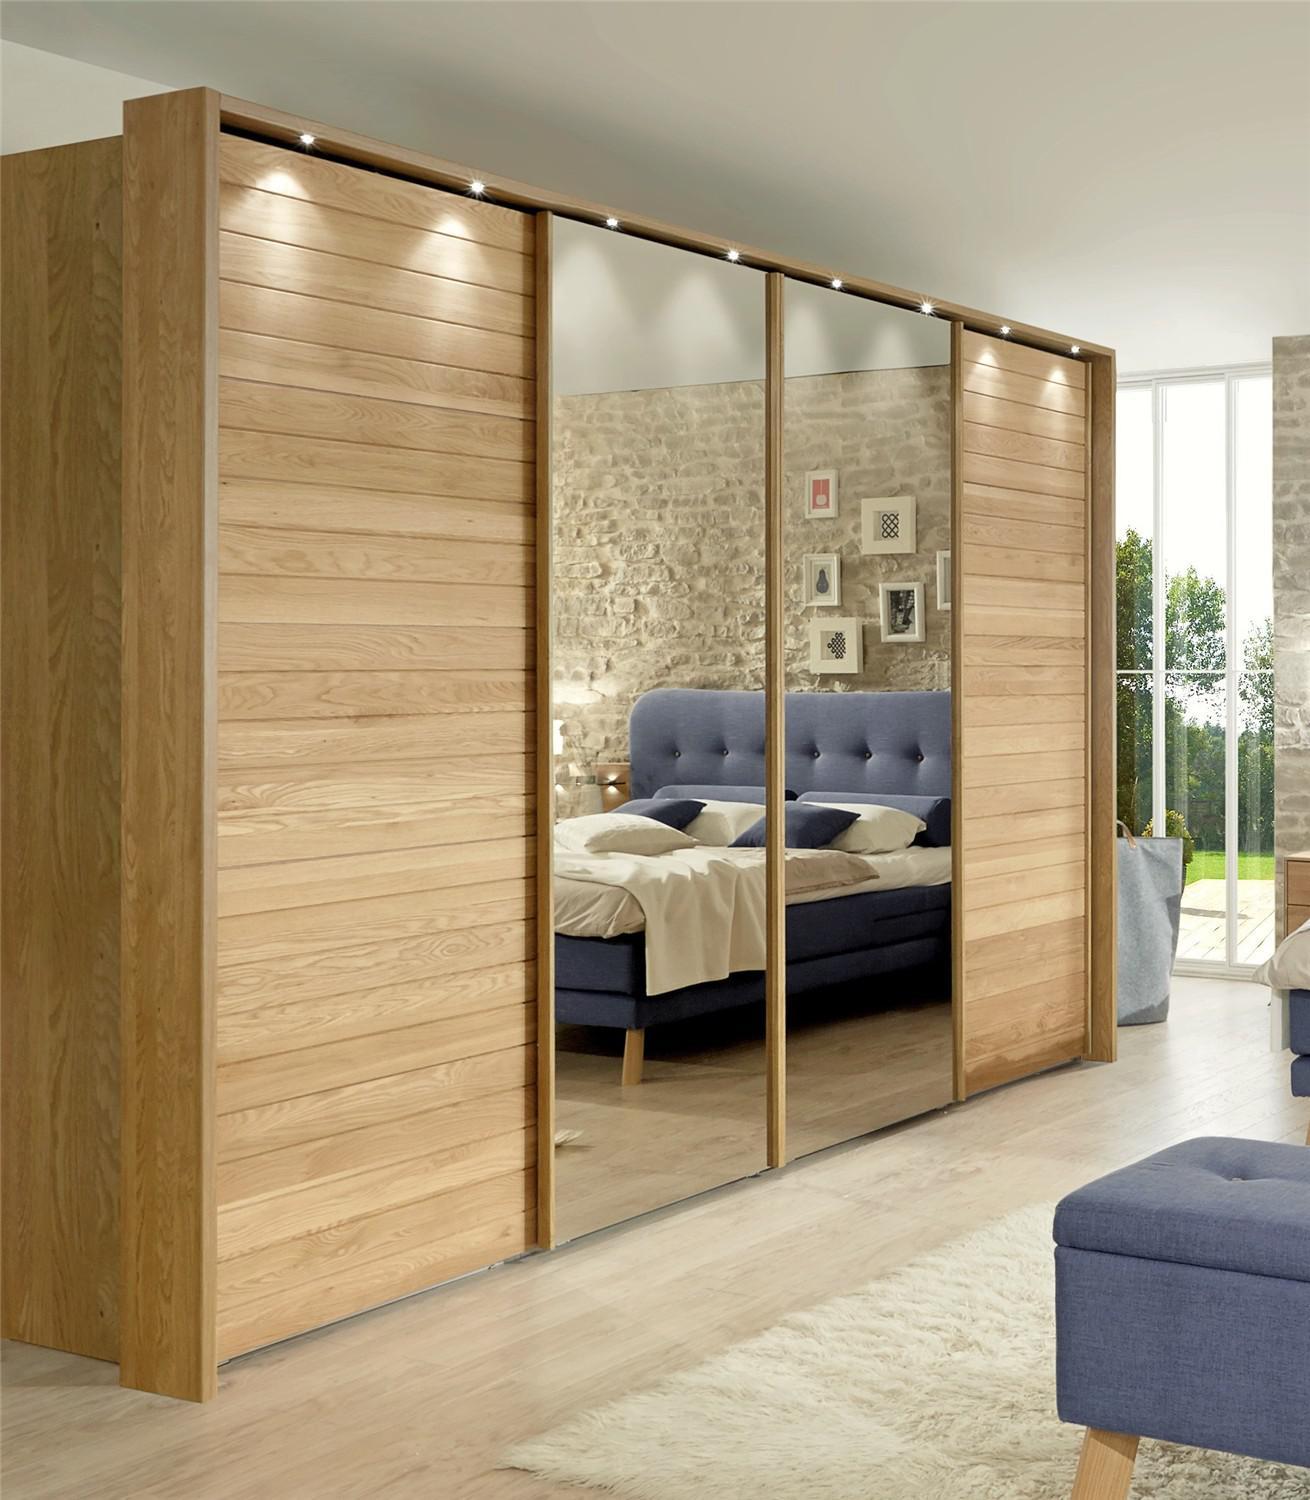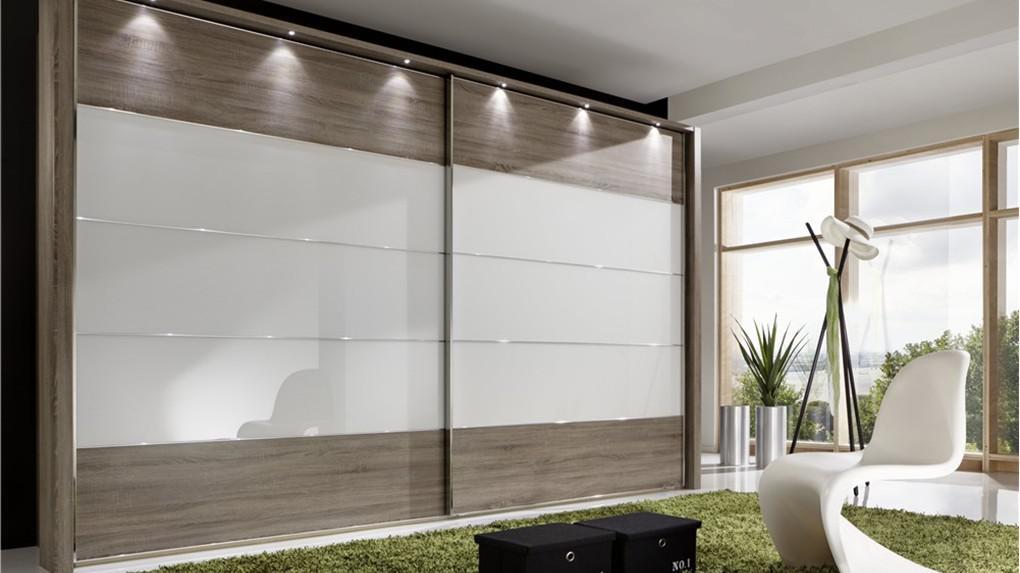The first image is the image on the left, the second image is the image on the right. Evaluate the accuracy of this statement regarding the images: "A plant is near a sliding cabinet in one of the images.". Is it true? Answer yes or no. Yes. The first image is the image on the left, the second image is the image on the right. Assess this claim about the two images: "An image shows a closed sliding-door unit with at least one mirrored center panel flanked by brown wood panels on the sides.". Correct or not? Answer yes or no. Yes. 